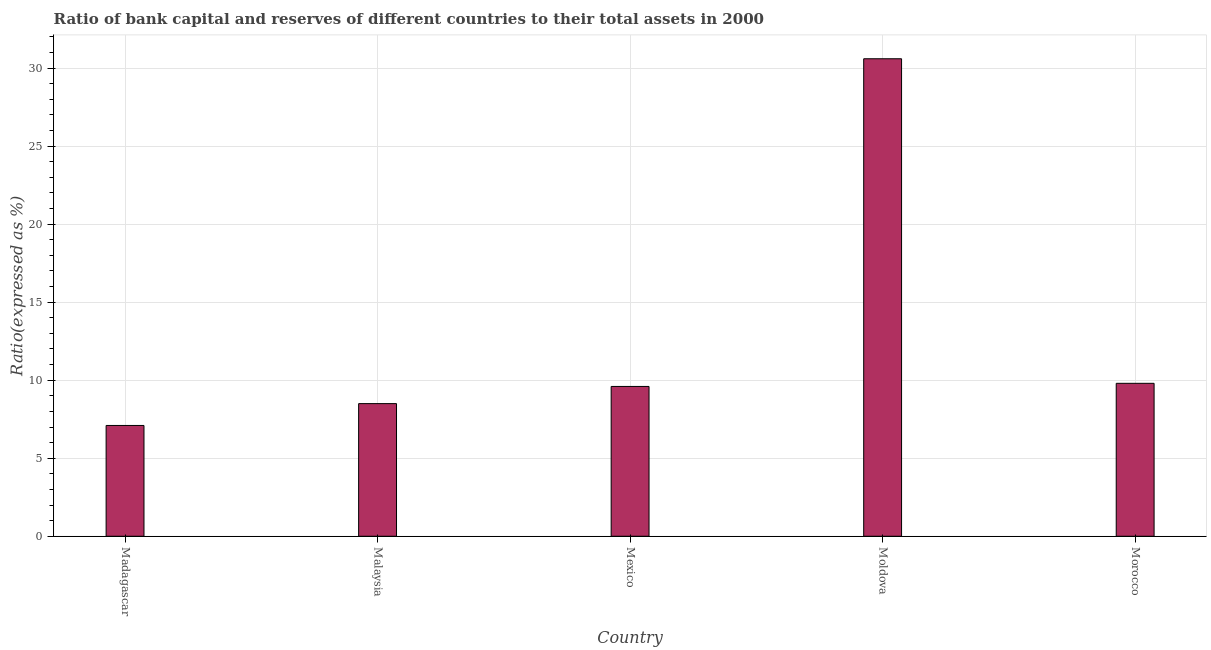Does the graph contain grids?
Provide a short and direct response. Yes. What is the title of the graph?
Your answer should be compact. Ratio of bank capital and reserves of different countries to their total assets in 2000. What is the label or title of the X-axis?
Offer a very short reply. Country. What is the label or title of the Y-axis?
Give a very brief answer. Ratio(expressed as %). What is the bank capital to assets ratio in Morocco?
Your response must be concise. 9.8. Across all countries, what is the maximum bank capital to assets ratio?
Make the answer very short. 30.6. Across all countries, what is the minimum bank capital to assets ratio?
Your answer should be very brief. 7.1. In which country was the bank capital to assets ratio maximum?
Your answer should be very brief. Moldova. In which country was the bank capital to assets ratio minimum?
Provide a succinct answer. Madagascar. What is the sum of the bank capital to assets ratio?
Ensure brevity in your answer.  65.6. What is the difference between the bank capital to assets ratio in Malaysia and Moldova?
Offer a very short reply. -22.1. What is the average bank capital to assets ratio per country?
Give a very brief answer. 13.12. What is the median bank capital to assets ratio?
Provide a succinct answer. 9.6. What is the ratio of the bank capital to assets ratio in Madagascar to that in Morocco?
Give a very brief answer. 0.72. Is the difference between the bank capital to assets ratio in Madagascar and Morocco greater than the difference between any two countries?
Offer a terse response. No. What is the difference between the highest and the second highest bank capital to assets ratio?
Offer a terse response. 20.8. What is the difference between the highest and the lowest bank capital to assets ratio?
Provide a short and direct response. 23.5. In how many countries, is the bank capital to assets ratio greater than the average bank capital to assets ratio taken over all countries?
Offer a terse response. 1. What is the Ratio(expressed as %) in Malaysia?
Give a very brief answer. 8.5. What is the Ratio(expressed as %) in Mexico?
Your answer should be very brief. 9.6. What is the Ratio(expressed as %) in Moldova?
Offer a very short reply. 30.6. What is the difference between the Ratio(expressed as %) in Madagascar and Malaysia?
Offer a terse response. -1.4. What is the difference between the Ratio(expressed as %) in Madagascar and Moldova?
Offer a very short reply. -23.5. What is the difference between the Ratio(expressed as %) in Madagascar and Morocco?
Provide a succinct answer. -2.7. What is the difference between the Ratio(expressed as %) in Malaysia and Moldova?
Your answer should be very brief. -22.1. What is the difference between the Ratio(expressed as %) in Malaysia and Morocco?
Provide a succinct answer. -1.3. What is the difference between the Ratio(expressed as %) in Mexico and Moldova?
Provide a succinct answer. -21. What is the difference between the Ratio(expressed as %) in Moldova and Morocco?
Your answer should be very brief. 20.8. What is the ratio of the Ratio(expressed as %) in Madagascar to that in Malaysia?
Your answer should be very brief. 0.83. What is the ratio of the Ratio(expressed as %) in Madagascar to that in Mexico?
Provide a succinct answer. 0.74. What is the ratio of the Ratio(expressed as %) in Madagascar to that in Moldova?
Make the answer very short. 0.23. What is the ratio of the Ratio(expressed as %) in Madagascar to that in Morocco?
Provide a succinct answer. 0.72. What is the ratio of the Ratio(expressed as %) in Malaysia to that in Mexico?
Give a very brief answer. 0.89. What is the ratio of the Ratio(expressed as %) in Malaysia to that in Moldova?
Keep it short and to the point. 0.28. What is the ratio of the Ratio(expressed as %) in Malaysia to that in Morocco?
Make the answer very short. 0.87. What is the ratio of the Ratio(expressed as %) in Mexico to that in Moldova?
Give a very brief answer. 0.31. What is the ratio of the Ratio(expressed as %) in Mexico to that in Morocco?
Offer a terse response. 0.98. What is the ratio of the Ratio(expressed as %) in Moldova to that in Morocco?
Ensure brevity in your answer.  3.12. 